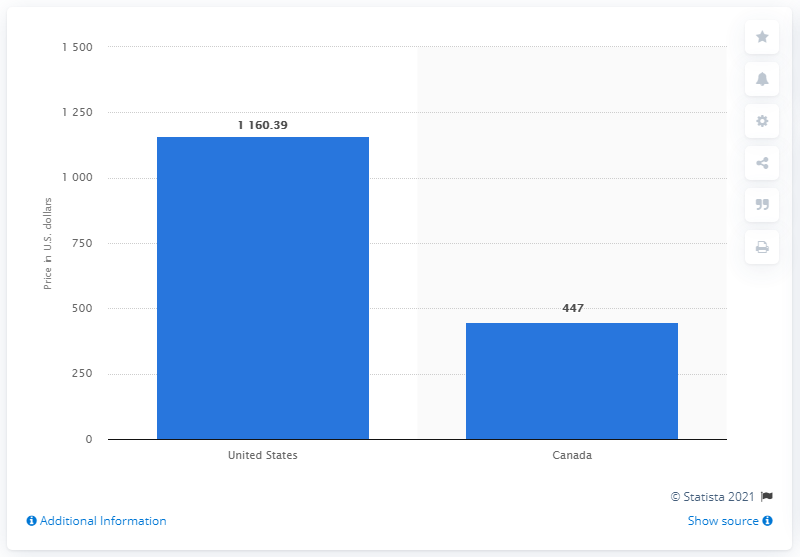Outline some significant characteristics in this image. The cost of a three-month supply of Lantus Solostar in the United States was approximately $1160.39. 